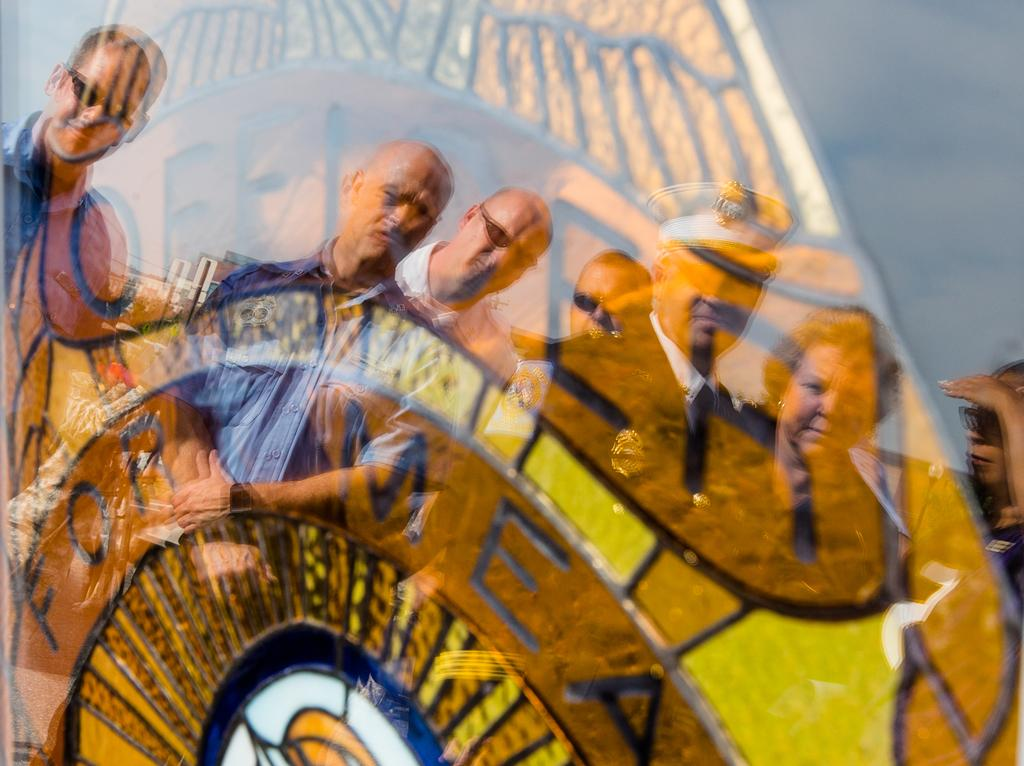What object is present in the image that can hold a liquid? There is a glass in the image. What is located behind the glass in the image? There is a poster behind the glass. What can be seen on the surface of the glass in the image? The reflections of people are visible on the glass. How many sisters are depicted in the image? There are no sisters present in the image. What is the amount of water in the glass in the image? The image does not provide information about the amount of water in the glass, if any. 